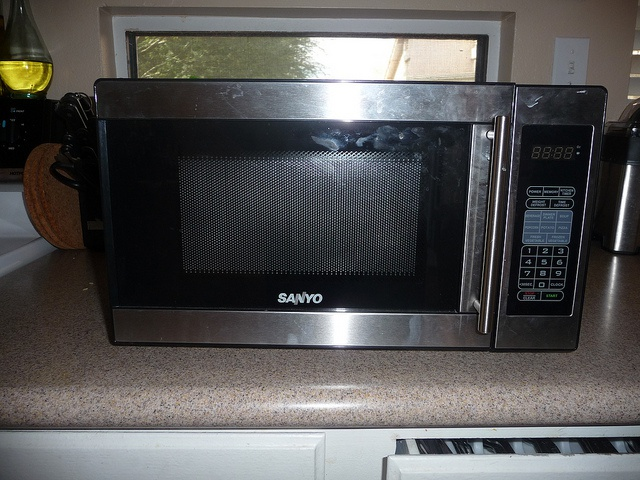Describe the objects in this image and their specific colors. I can see microwave in black, gray, darkgray, and white tones, knife in black and gray tones, and knife in black and gray tones in this image. 